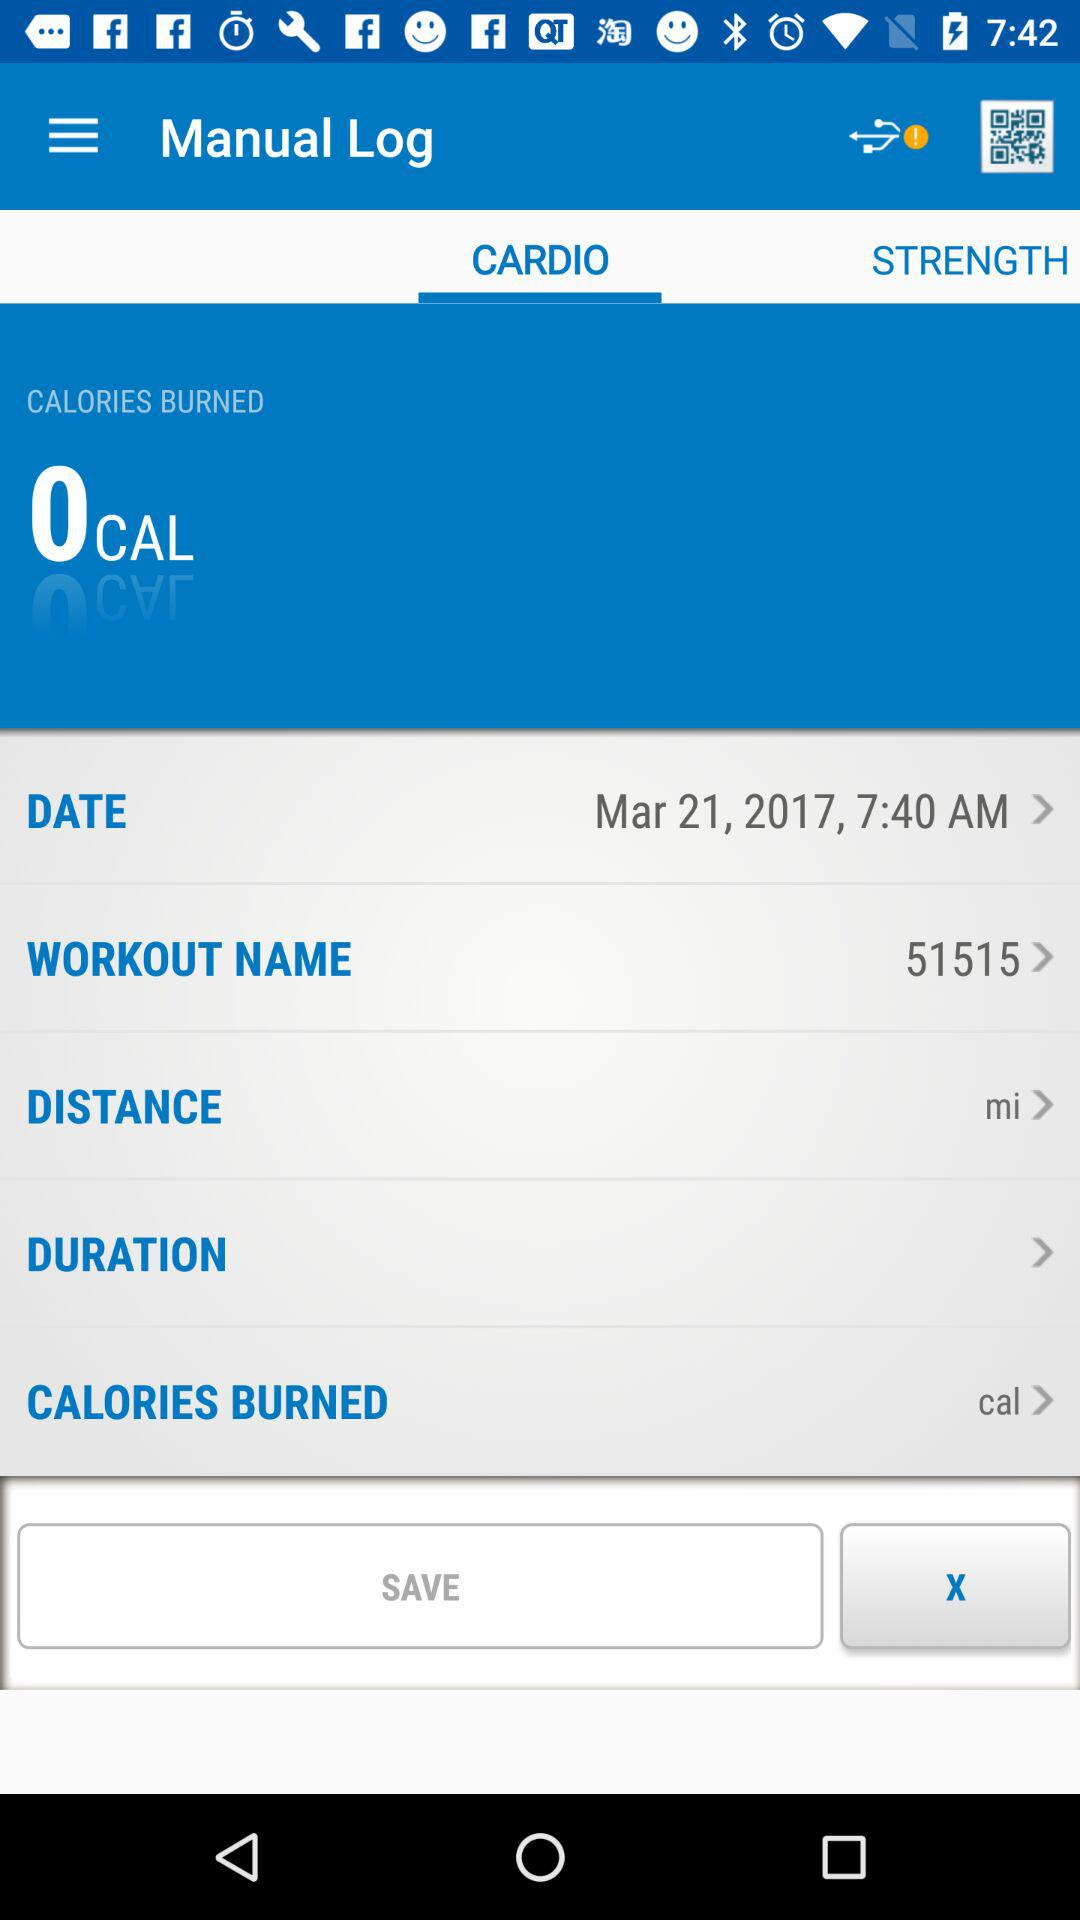How many calories did the user burn during this workout?
Answer the question using a single word or phrase. 0 